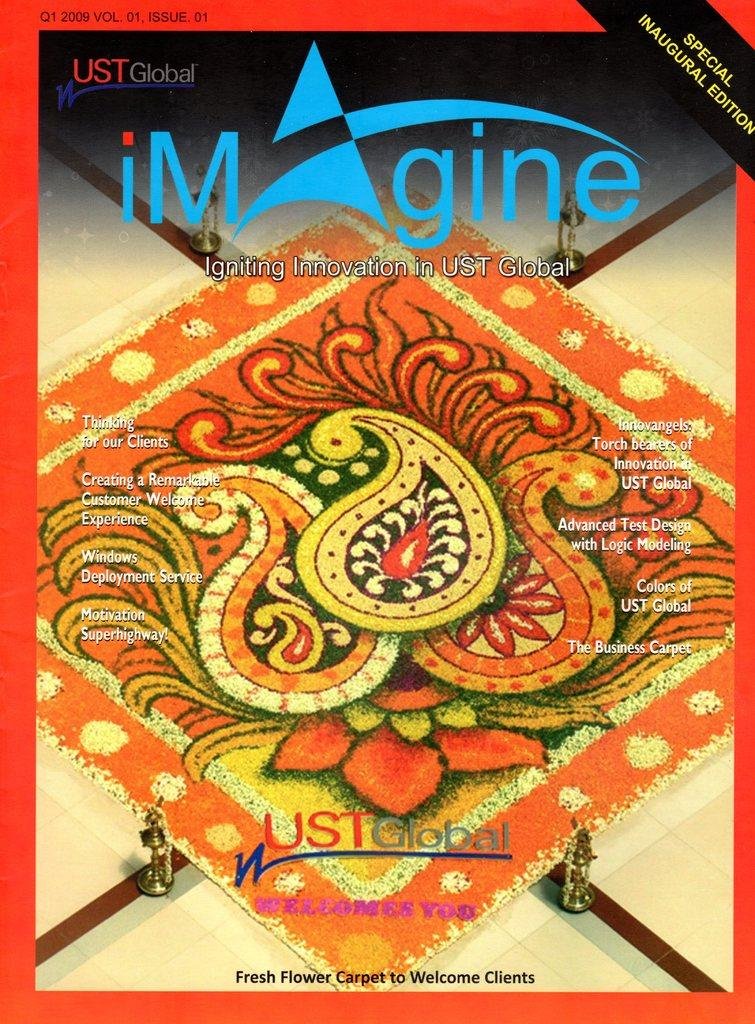<image>
Provide a brief description of the given image. A magazine cover for a special inaugural edition of the magazine Imagine. 